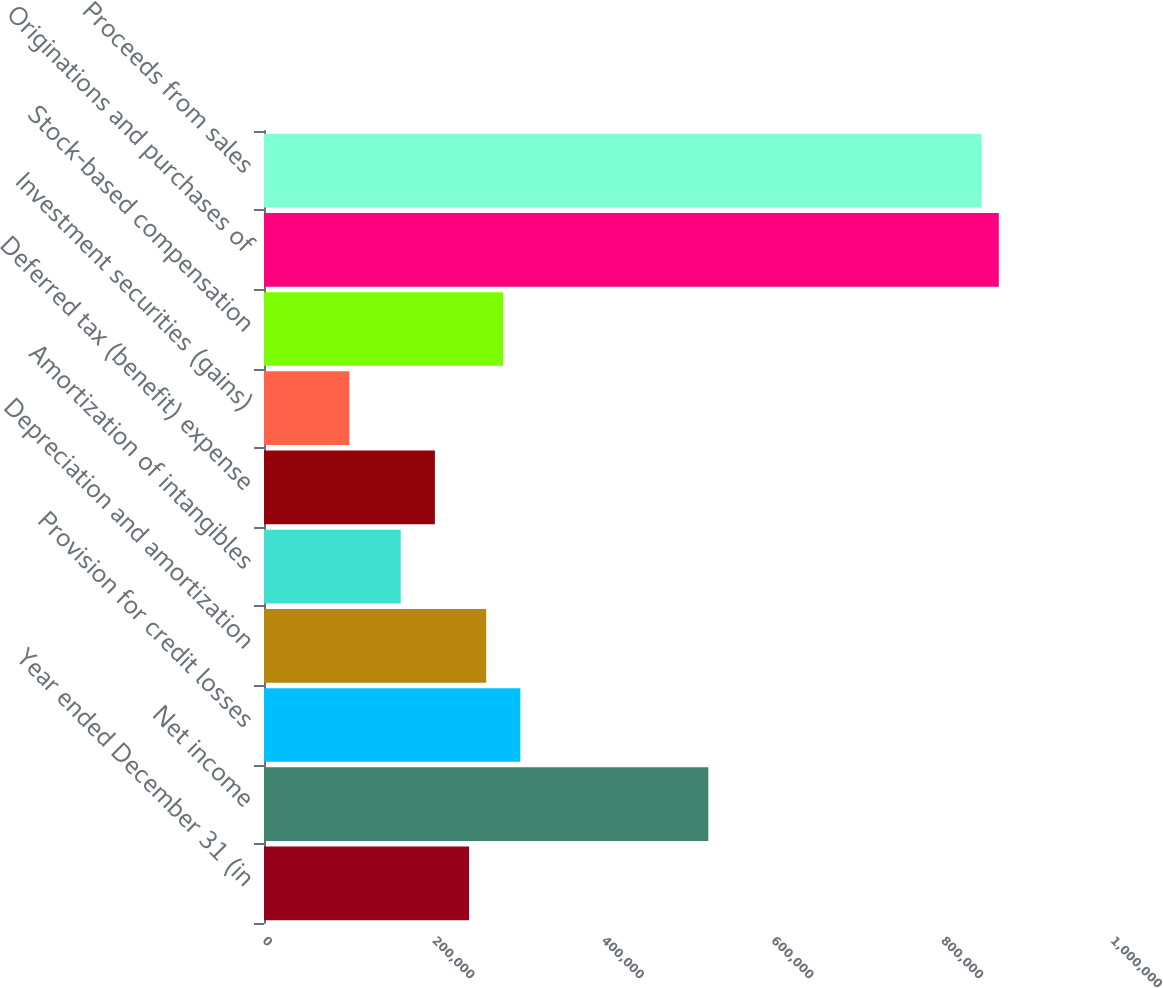<chart> <loc_0><loc_0><loc_500><loc_500><bar_chart><fcel>Year ended December 31 (in<fcel>Net income<fcel>Provision for credit losses<fcel>Depreciation and amortization<fcel>Amortization of intangibles<fcel>Deferred tax (benefit) expense<fcel>Investment securities (gains)<fcel>Stock-based compensation<fcel>Originations and purchases of<fcel>Proceeds from sales<nl><fcel>241832<fcel>523948<fcel>302286<fcel>261983<fcel>161228<fcel>201530<fcel>100774<fcel>282134<fcel>866516<fcel>846365<nl></chart> 